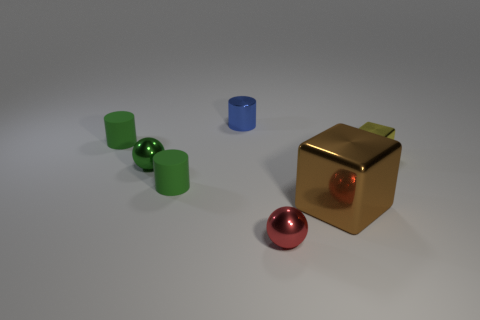Is the material of the sphere right of the tiny blue cylinder the same as the brown block?
Keep it short and to the point. Yes. How many tiny shiny things are both in front of the green metal object and behind the tiny red ball?
Provide a short and direct response. 0. What number of small green spheres have the same material as the small red object?
Ensure brevity in your answer.  1. What color is the cylinder that is made of the same material as the tiny red object?
Your answer should be very brief. Blue. Are there fewer small matte balls than tiny yellow blocks?
Provide a short and direct response. Yes. What is the material of the tiny green cylinder on the right side of the tiny green matte thing to the left of the sphere that is on the left side of the tiny red sphere?
Give a very brief answer. Rubber. What material is the blue cylinder?
Give a very brief answer. Metal. Do the metallic object that is on the left side of the blue thing and the tiny matte object that is behind the tiny green shiny thing have the same color?
Give a very brief answer. Yes. Is the number of big cyan metal cylinders greater than the number of shiny blocks?
Your response must be concise. No. What color is the other thing that is the same shape as the small red shiny thing?
Ensure brevity in your answer.  Green. 